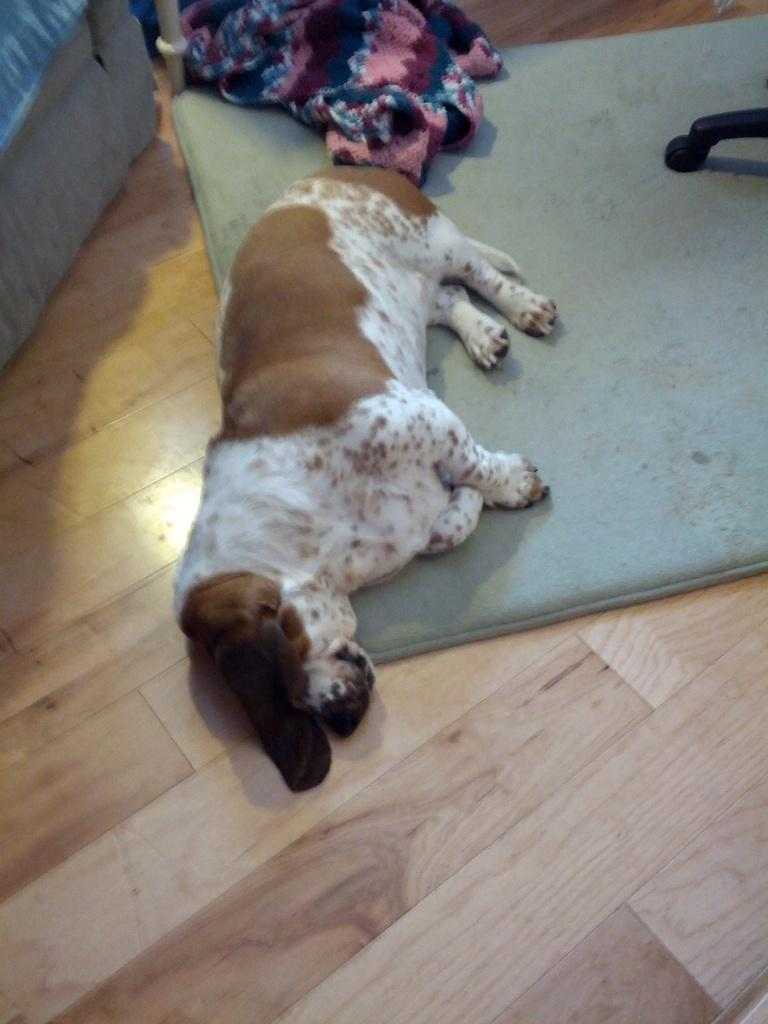What type of animal is in the image? There is a dog in the image. What is the dog doing in the image? The dog is laying on a carpet. What is the carpet placed on? The carpet is on a wooden floor. What furniture can be seen in the image? There is a wooden sofa in the left side corner of the image. What additional item is present in the image? There is a wheelchair in the right side of the image. What type of tooth is visible in the image? There is no tooth present in the image. What color is the sky in the image? The image does not show the sky, so we cannot determine its color. 